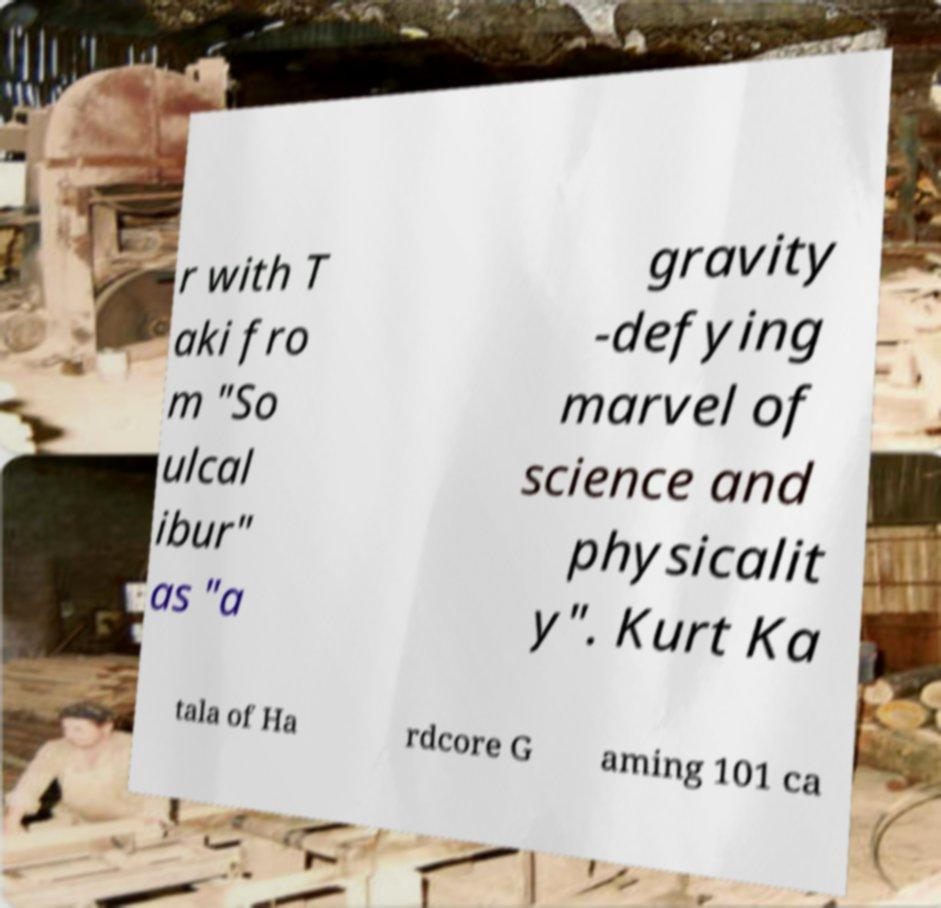Can you read and provide the text displayed in the image?This photo seems to have some interesting text. Can you extract and type it out for me? r with T aki fro m "So ulcal ibur" as "a gravity -defying marvel of science and physicalit y". Kurt Ka tala of Ha rdcore G aming 101 ca 